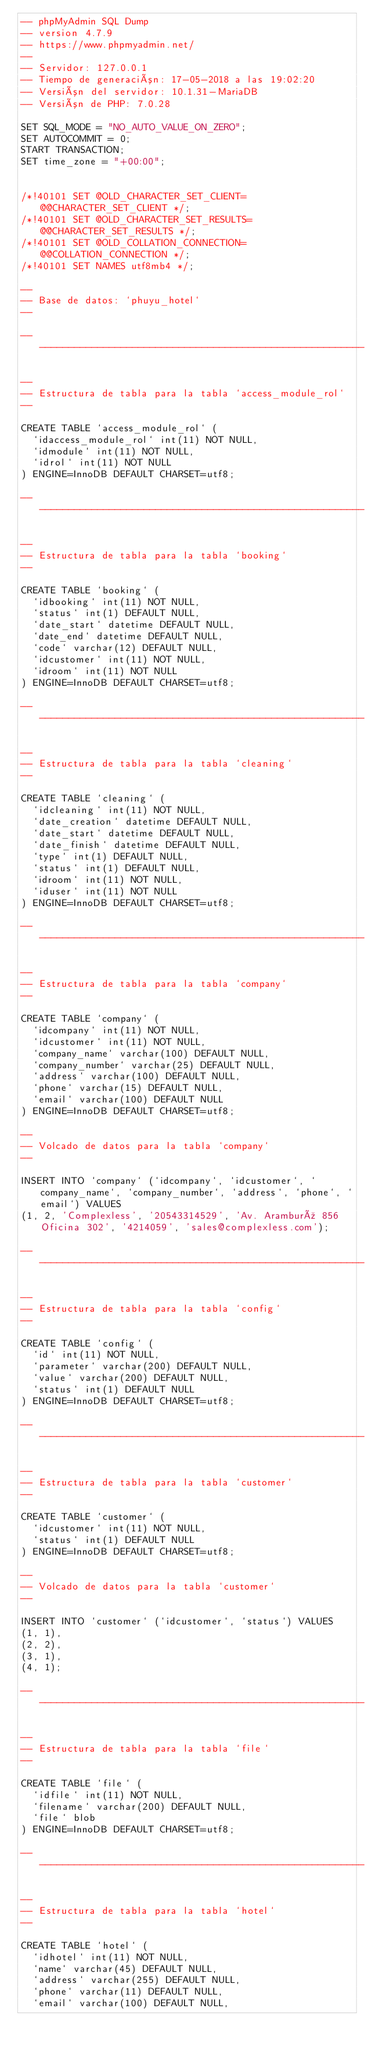<code> <loc_0><loc_0><loc_500><loc_500><_SQL_>-- phpMyAdmin SQL Dump
-- version 4.7.9
-- https://www.phpmyadmin.net/
--
-- Servidor: 127.0.0.1
-- Tiempo de generación: 17-05-2018 a las 19:02:20
-- Versión del servidor: 10.1.31-MariaDB
-- Versión de PHP: 7.0.28

SET SQL_MODE = "NO_AUTO_VALUE_ON_ZERO";
SET AUTOCOMMIT = 0;
START TRANSACTION;
SET time_zone = "+00:00";


/*!40101 SET @OLD_CHARACTER_SET_CLIENT=@@CHARACTER_SET_CLIENT */;
/*!40101 SET @OLD_CHARACTER_SET_RESULTS=@@CHARACTER_SET_RESULTS */;
/*!40101 SET @OLD_COLLATION_CONNECTION=@@COLLATION_CONNECTION */;
/*!40101 SET NAMES utf8mb4 */;

--
-- Base de datos: `phuyu_hotel`
--

-- --------------------------------------------------------

--
-- Estructura de tabla para la tabla `access_module_rol`
--

CREATE TABLE `access_module_rol` (
  `idaccess_module_rol` int(11) NOT NULL,
  `idmodule` int(11) NOT NULL,
  `idrol` int(11) NOT NULL
) ENGINE=InnoDB DEFAULT CHARSET=utf8;

-- --------------------------------------------------------

--
-- Estructura de tabla para la tabla `booking`
--

CREATE TABLE `booking` (
  `idbooking` int(11) NOT NULL,
  `status` int(1) DEFAULT NULL,
  `date_start` datetime DEFAULT NULL,
  `date_end` datetime DEFAULT NULL,
  `code` varchar(12) DEFAULT NULL,
  `idcustomer` int(11) NOT NULL,
  `idroom` int(11) NOT NULL
) ENGINE=InnoDB DEFAULT CHARSET=utf8;

-- --------------------------------------------------------

--
-- Estructura de tabla para la tabla `cleaning`
--

CREATE TABLE `cleaning` (
  `idcleaning` int(11) NOT NULL,
  `date_creation` datetime DEFAULT NULL,
  `date_start` datetime DEFAULT NULL,
  `date_finish` datetime DEFAULT NULL,
  `type` int(1) DEFAULT NULL,
  `status` int(1) DEFAULT NULL,
  `idroom` int(11) NOT NULL,
  `iduser` int(11) NOT NULL
) ENGINE=InnoDB DEFAULT CHARSET=utf8;

-- --------------------------------------------------------

--
-- Estructura de tabla para la tabla `company`
--

CREATE TABLE `company` (
  `idcompany` int(11) NOT NULL,
  `idcustomer` int(11) NOT NULL,
  `company_name` varchar(100) DEFAULT NULL,
  `company_number` varchar(25) DEFAULT NULL,
  `address` varchar(100) DEFAULT NULL,
  `phone` varchar(15) DEFAULT NULL,
  `email` varchar(100) DEFAULT NULL
) ENGINE=InnoDB DEFAULT CHARSET=utf8;

--
-- Volcado de datos para la tabla `company`
--

INSERT INTO `company` (`idcompany`, `idcustomer`, `company_name`, `company_number`, `address`, `phone`, `email`) VALUES
(1, 2, 'Complexless', '20543314529', 'Av. Aramburú 856 Oficina 302', '4214059', 'sales@complexless.com');

-- --------------------------------------------------------

--
-- Estructura de tabla para la tabla `config`
--

CREATE TABLE `config` (
  `id` int(11) NOT NULL,
  `parameter` varchar(200) DEFAULT NULL,
  `value` varchar(200) DEFAULT NULL,
  `status` int(1) DEFAULT NULL
) ENGINE=InnoDB DEFAULT CHARSET=utf8;

-- --------------------------------------------------------

--
-- Estructura de tabla para la tabla `customer`
--

CREATE TABLE `customer` (
  `idcustomer` int(11) NOT NULL,
  `status` int(1) DEFAULT NULL
) ENGINE=InnoDB DEFAULT CHARSET=utf8;

--
-- Volcado de datos para la tabla `customer`
--

INSERT INTO `customer` (`idcustomer`, `status`) VALUES
(1, 1),
(2, 2),
(3, 1),
(4, 1);

-- --------------------------------------------------------

--
-- Estructura de tabla para la tabla `file`
--

CREATE TABLE `file` (
  `idfile` int(11) NOT NULL,
  `filename` varchar(200) DEFAULT NULL,
  `file` blob
) ENGINE=InnoDB DEFAULT CHARSET=utf8;

-- --------------------------------------------------------

--
-- Estructura de tabla para la tabla `hotel`
--

CREATE TABLE `hotel` (
  `idhotel` int(11) NOT NULL,
  `name` varchar(45) DEFAULT NULL,
  `address` varchar(255) DEFAULT NULL,
  `phone` varchar(11) DEFAULT NULL,
  `email` varchar(100) DEFAULT NULL,</code> 